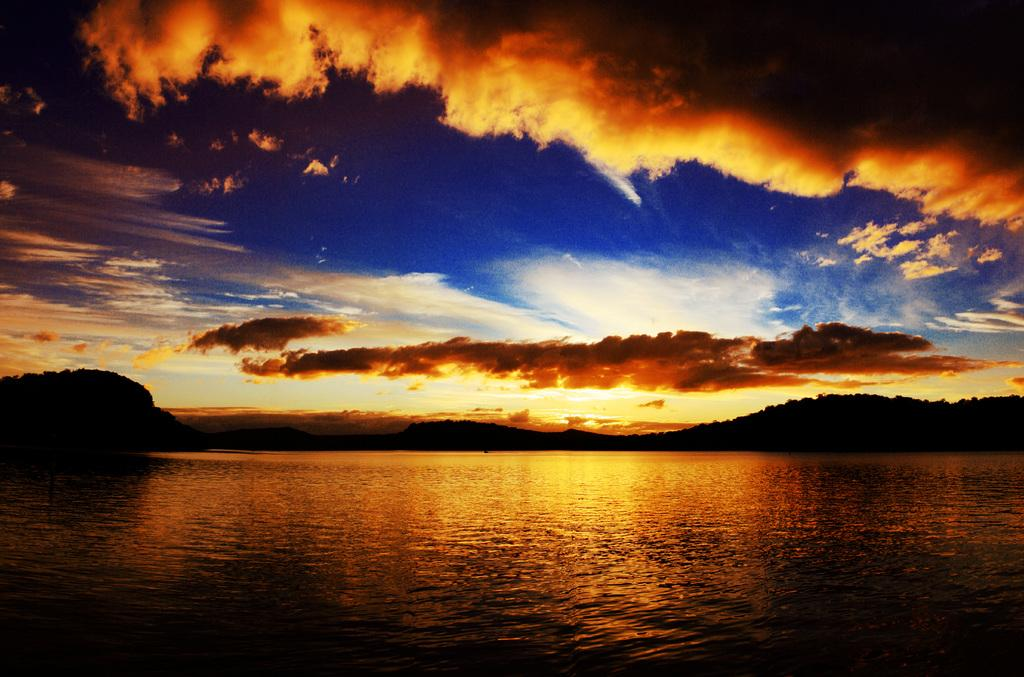What is at the bottom of the image? There is water at the bottom of the image. What can be seen at the top of the image? The sky is visible at the top of the image. What is present in the sky? Clouds are present in the sky. What type of vegetation or plants can be seen in the middle of the image? There appears to be greenery in the middle of the image. How many slaves are being used as fuel in the image? There is no reference to slaves or fuel in the image; it features water, sky, clouds, and greenery. 